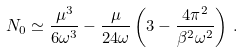<formula> <loc_0><loc_0><loc_500><loc_500>N _ { 0 } \simeq \frac { \mu ^ { 3 } } { 6 \omega ^ { 3 } } - \frac { \mu } { 2 4 \omega } \left ( 3 - \frac { 4 \pi ^ { 2 } } { \beta ^ { 2 } \omega ^ { 2 } } \right ) \, .</formula> 